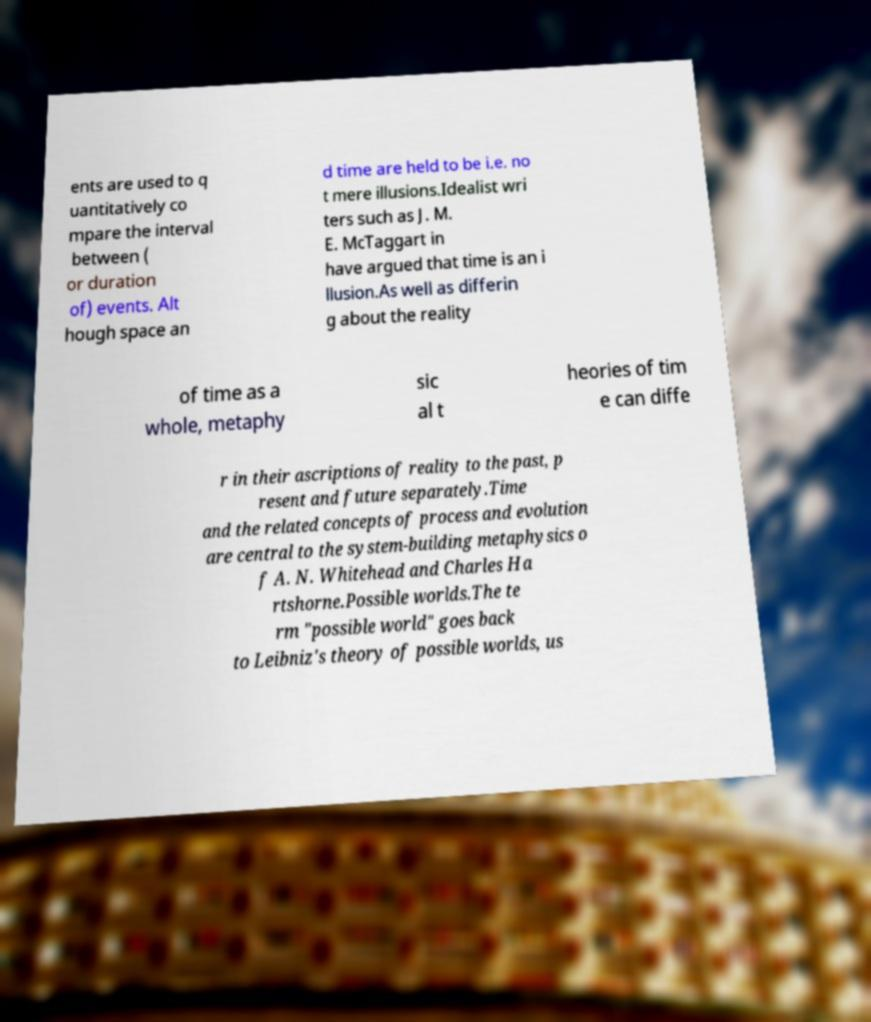There's text embedded in this image that I need extracted. Can you transcribe it verbatim? ents are used to q uantitatively co mpare the interval between ( or duration of) events. Alt hough space an d time are held to be i.e. no t mere illusions.Idealist wri ters such as J. M. E. McTaggart in have argued that time is an i llusion.As well as differin g about the reality of time as a whole, metaphy sic al t heories of tim e can diffe r in their ascriptions of reality to the past, p resent and future separately.Time and the related concepts of process and evolution are central to the system-building metaphysics o f A. N. Whitehead and Charles Ha rtshorne.Possible worlds.The te rm "possible world" goes back to Leibniz's theory of possible worlds, us 